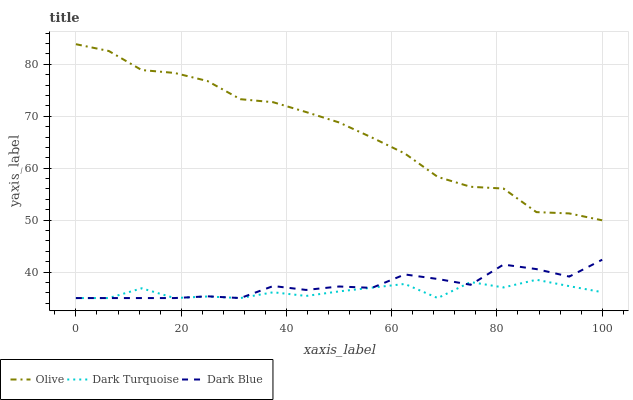Does Dark Turquoise have the minimum area under the curve?
Answer yes or no. Yes. Does Olive have the maximum area under the curve?
Answer yes or no. Yes. Does Dark Blue have the minimum area under the curve?
Answer yes or no. No. Does Dark Blue have the maximum area under the curve?
Answer yes or no. No. Is Olive the smoothest?
Answer yes or no. Yes. Is Dark Turquoise the roughest?
Answer yes or no. Yes. Is Dark Blue the smoothest?
Answer yes or no. No. Is Dark Blue the roughest?
Answer yes or no. No. Does Dark Turquoise have the lowest value?
Answer yes or no. Yes. Does Olive have the highest value?
Answer yes or no. Yes. Does Dark Blue have the highest value?
Answer yes or no. No. Is Dark Blue less than Olive?
Answer yes or no. Yes. Is Olive greater than Dark Turquoise?
Answer yes or no. Yes. Does Dark Turquoise intersect Dark Blue?
Answer yes or no. Yes. Is Dark Turquoise less than Dark Blue?
Answer yes or no. No. Is Dark Turquoise greater than Dark Blue?
Answer yes or no. No. Does Dark Blue intersect Olive?
Answer yes or no. No. 